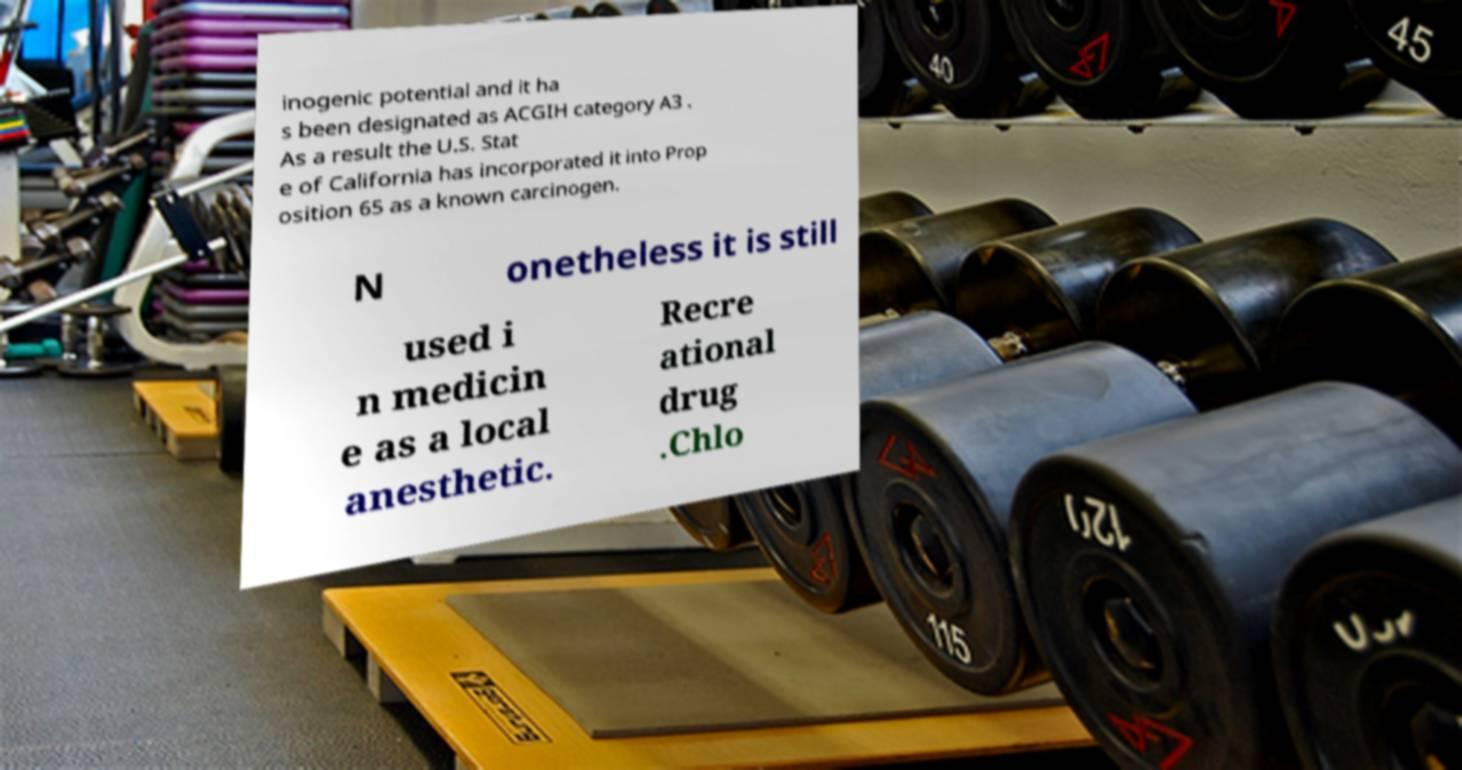Could you extract and type out the text from this image? inogenic potential and it ha s been designated as ACGIH category A3 . As a result the U.S. Stat e of California has incorporated it into Prop osition 65 as a known carcinogen. N onetheless it is still used i n medicin e as a local anesthetic. Recre ational drug .Chlo 